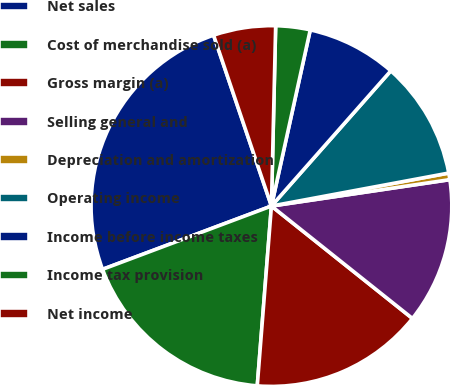Convert chart. <chart><loc_0><loc_0><loc_500><loc_500><pie_chart><fcel>Net sales<fcel>Cost of merchandise sold (a)<fcel>Gross margin (a)<fcel>Selling general and<fcel>Depreciation and amortization<fcel>Operating income<fcel>Income before income taxes<fcel>Income tax provision<fcel>Net income<nl><fcel>25.51%<fcel>18.04%<fcel>15.54%<fcel>13.05%<fcel>0.59%<fcel>10.56%<fcel>8.06%<fcel>3.08%<fcel>5.57%<nl></chart> 